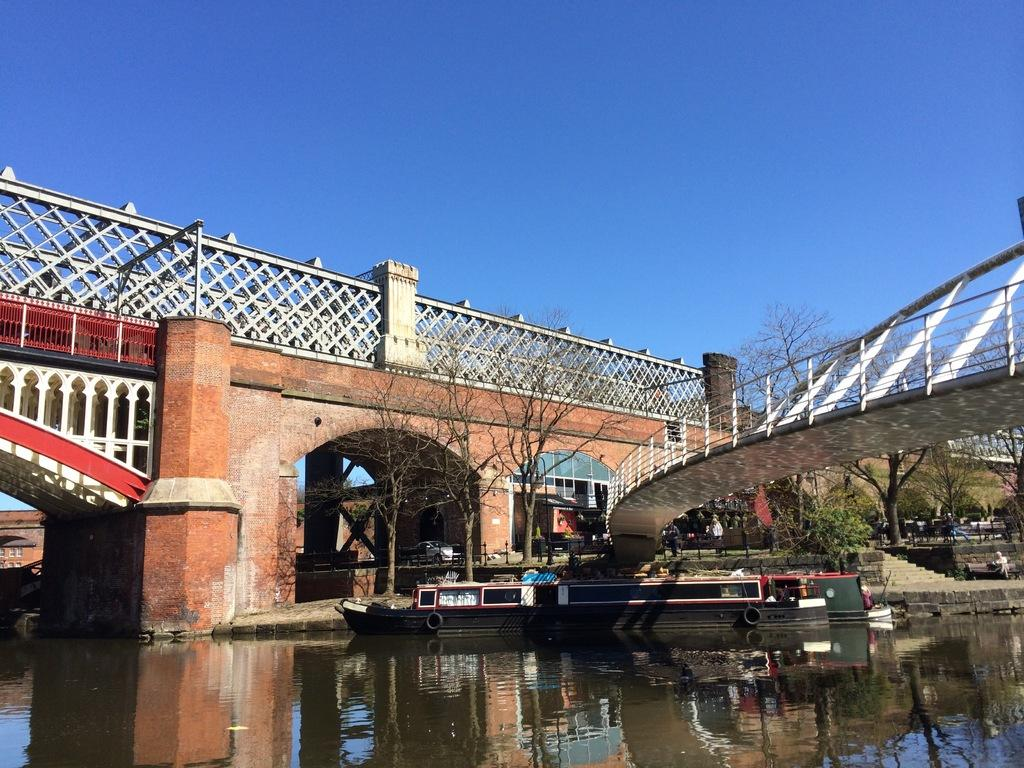What is on the water in the image? There is a boat on the water in the image. What type of vegetation can be seen in the image? There are trees visible in the image. What type of vehicle is present in the image? There is a car in the image. What type of structure can be seen in the image? There are boards and a building in the image. What type of seating is present in the image? There is a person sitting on a bench in the image. What type of man-made structure is present in the image? There is a bridge in the image. What part of the natural environment is visible in the background? The sky is visible in the background of the image. What type of birthday celebration is happening in the image? There is no indication of a birthday celebration in the image. What type of emotion is the person on the bench displaying in the image? The person's emotions cannot be determined from the image. What type of vegetable is being used as a decoration in the image? There is no vegetable, such as cabbage, present in the image. 